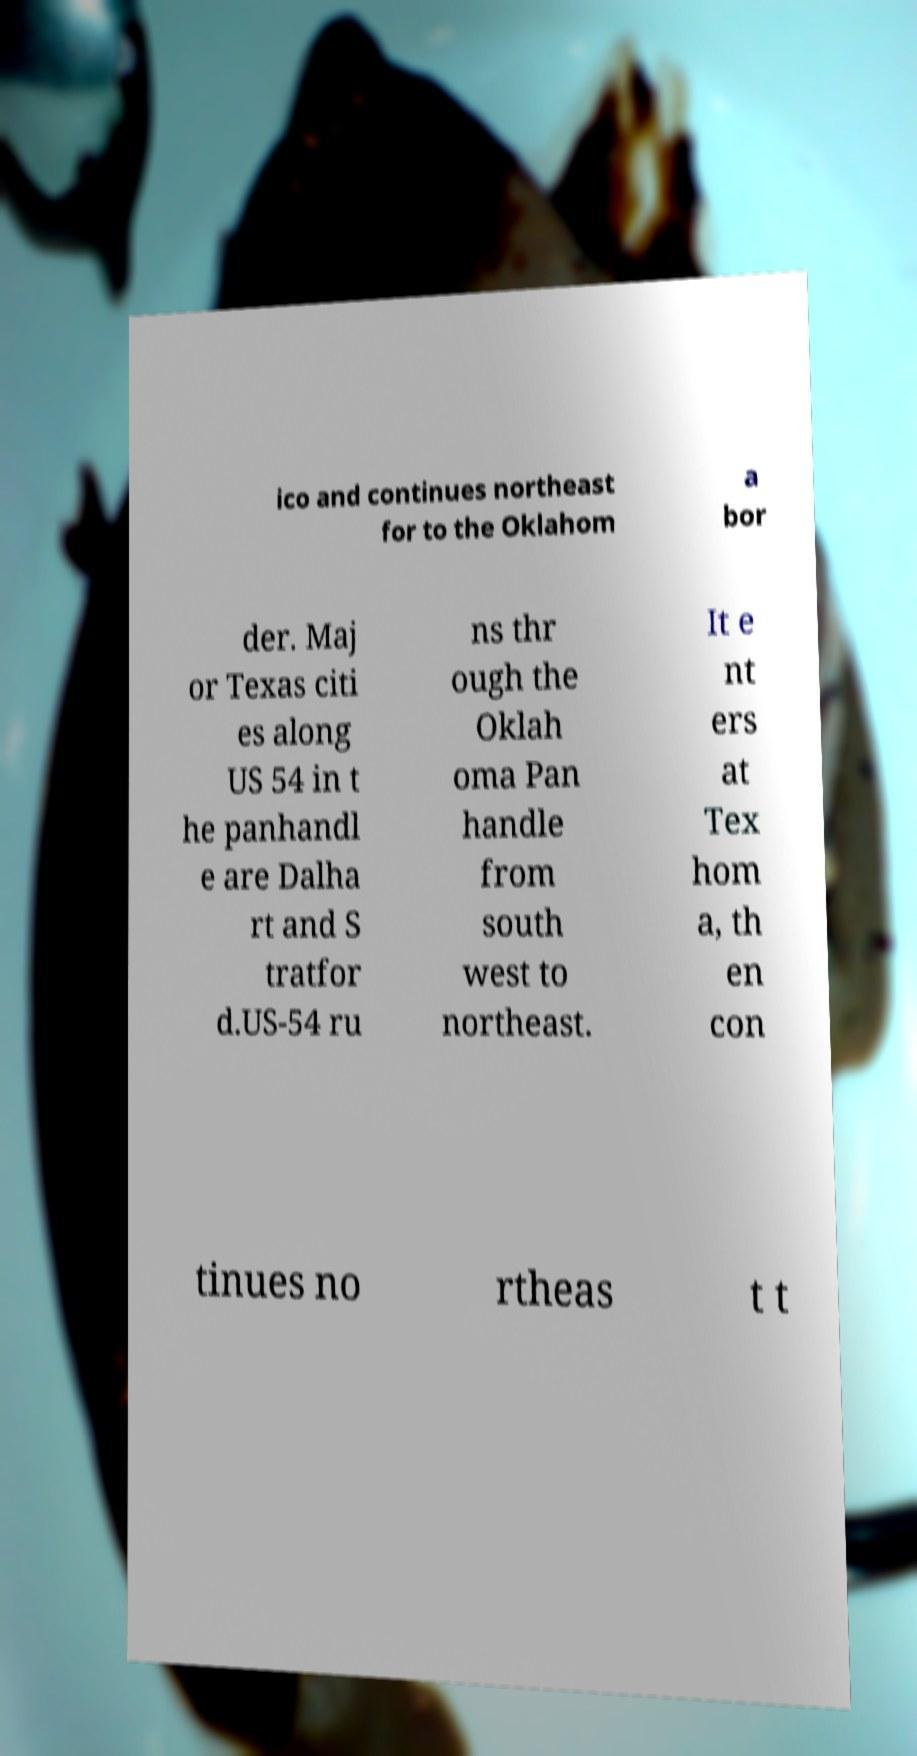Could you extract and type out the text from this image? ico and continues northeast for to the Oklahom a bor der. Maj or Texas citi es along US 54 in t he panhandl e are Dalha rt and S tratfor d.US-54 ru ns thr ough the Oklah oma Pan handle from south west to northeast. It e nt ers at Tex hom a, th en con tinues no rtheas t t 